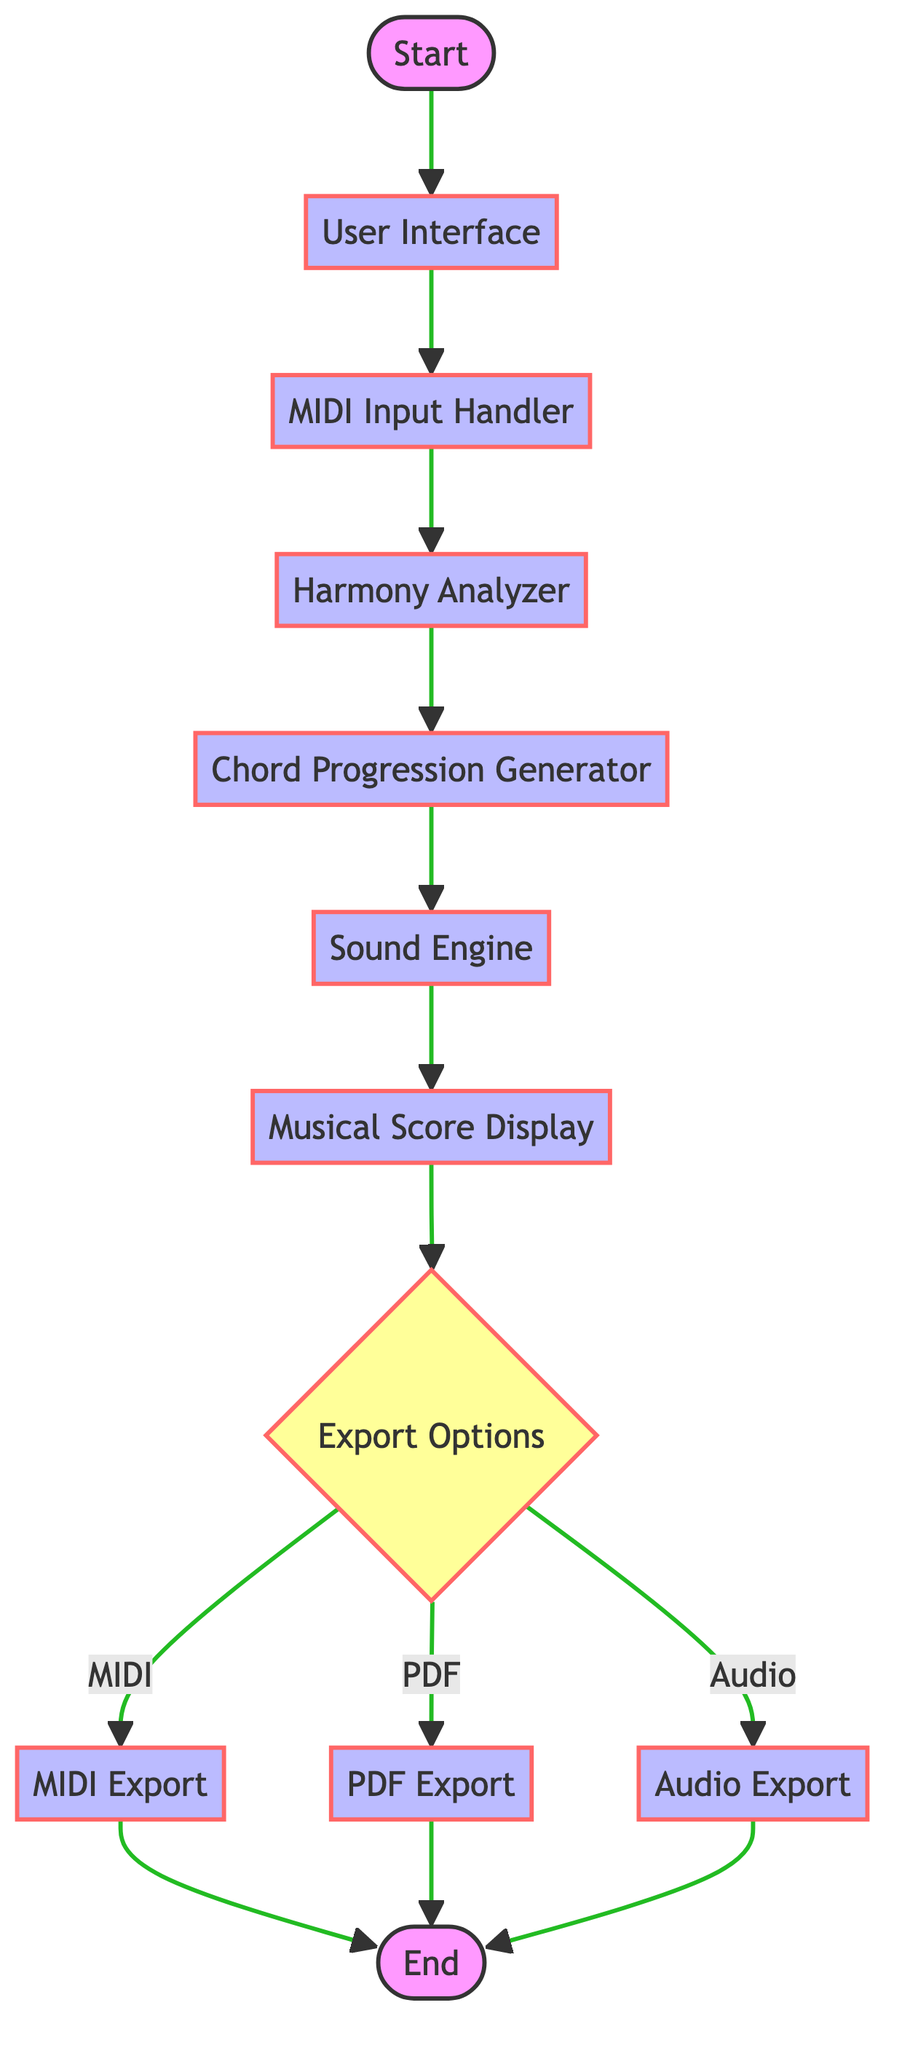What is the first process in the flowchart? The flowchart starts with the "User Interface" process, which is the first process that follows the start node.
Answer: User Interface How many decision nodes are present in the flowchart? The flowchart contains one decision node, which is the "Export Options" node where a choice is made regarding the export format.
Answer: 1 What does the "Harmony Analyzer" do? The "Harmony Analyzer" processes input by analyzing the melody for its harmonic structure, making it crucial for understanding the compositional framework.
Answer: Analyze melody for harmonic structure Which node follows the "Sound Engine"? After the "Sound Engine," the next process is the "Musical Score Display," which visualizes both generated and input music notation.
Answer: Musical Score Display What are the three export formats available in the "Export Options" decision node? The export formats available as options are MIDI, PDF, and audio, allowing users to choose how they want to save their compositions.
Answer: MIDI, PDF, Audio Which process comes before the "MIDI Export" node? The "MIDI Export" node is preceded by the "Export Options" decision node, which dictates the export'd format as MIDI in this case.
Answer: Export Options What is the final output stage in the flowchart? The final output stage in the flowchart is the "End" node, indicating the completion of the flow once any of the export processes have been carried out.
Answer: End Which process is executed after generating the chord progression? Once the chord progression is generated, the subsequent process is the "Sound Engine," responsible for rendering the audio output.
Answer: Sound Engine 